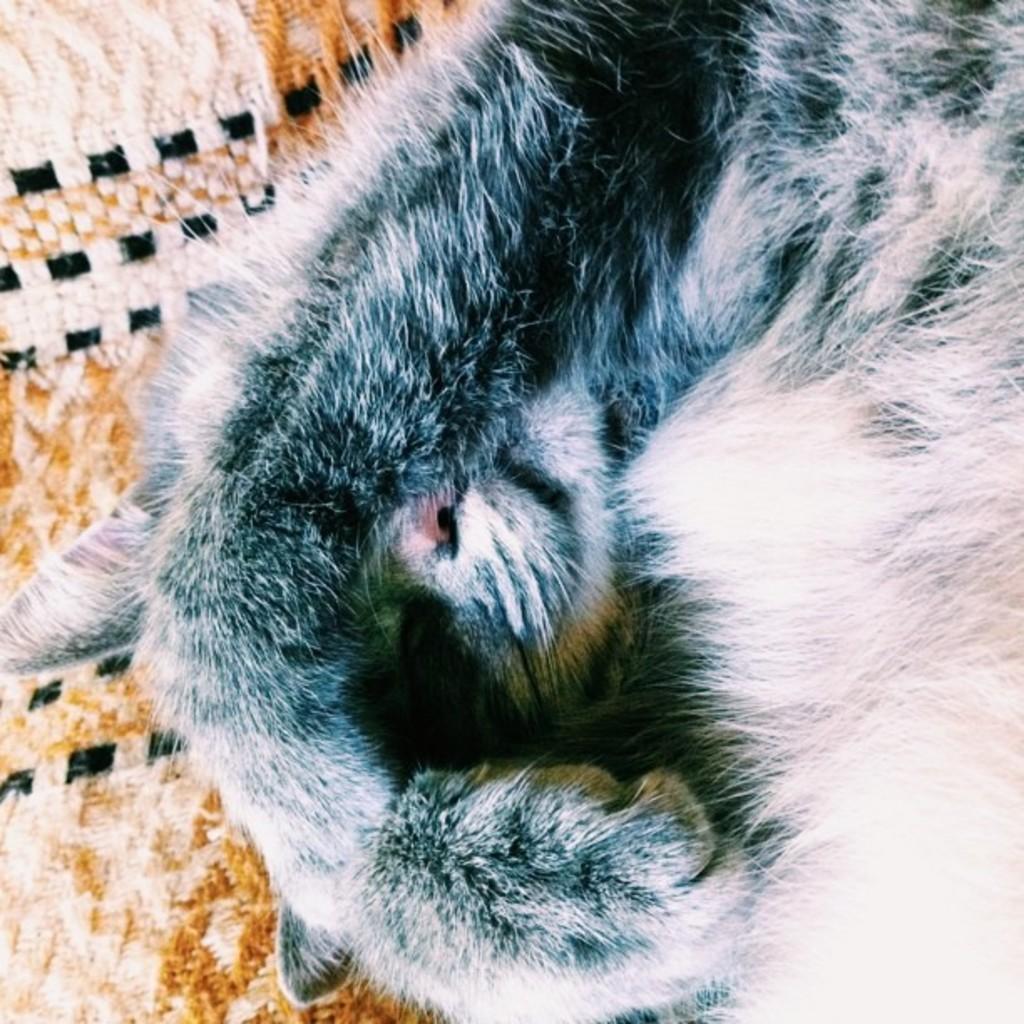Please provide a concise description of this image. In this image we can see a cat and in the background, we can see an object which looks like a cloth. 